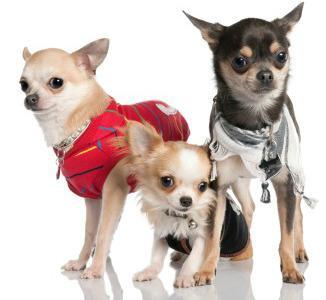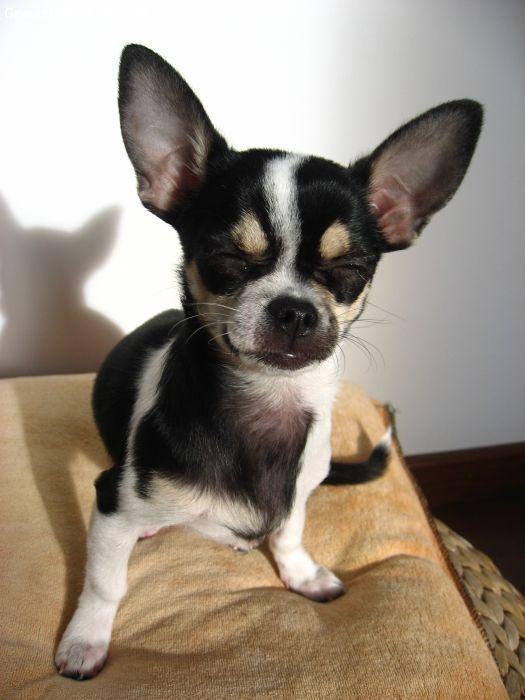The first image is the image on the left, the second image is the image on the right. Given the left and right images, does the statement "Each image contains three dogs, and one set of dogs pose wearing only collars." hold true? Answer yes or no. No. The first image is the image on the left, the second image is the image on the right. Evaluate the accuracy of this statement regarding the images: "There are three chihuahuas in the right image.". Is it true? Answer yes or no. No. 